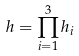Convert formula to latex. <formula><loc_0><loc_0><loc_500><loc_500>h = \prod _ { i = 1 } ^ { 3 } h _ { i }</formula> 